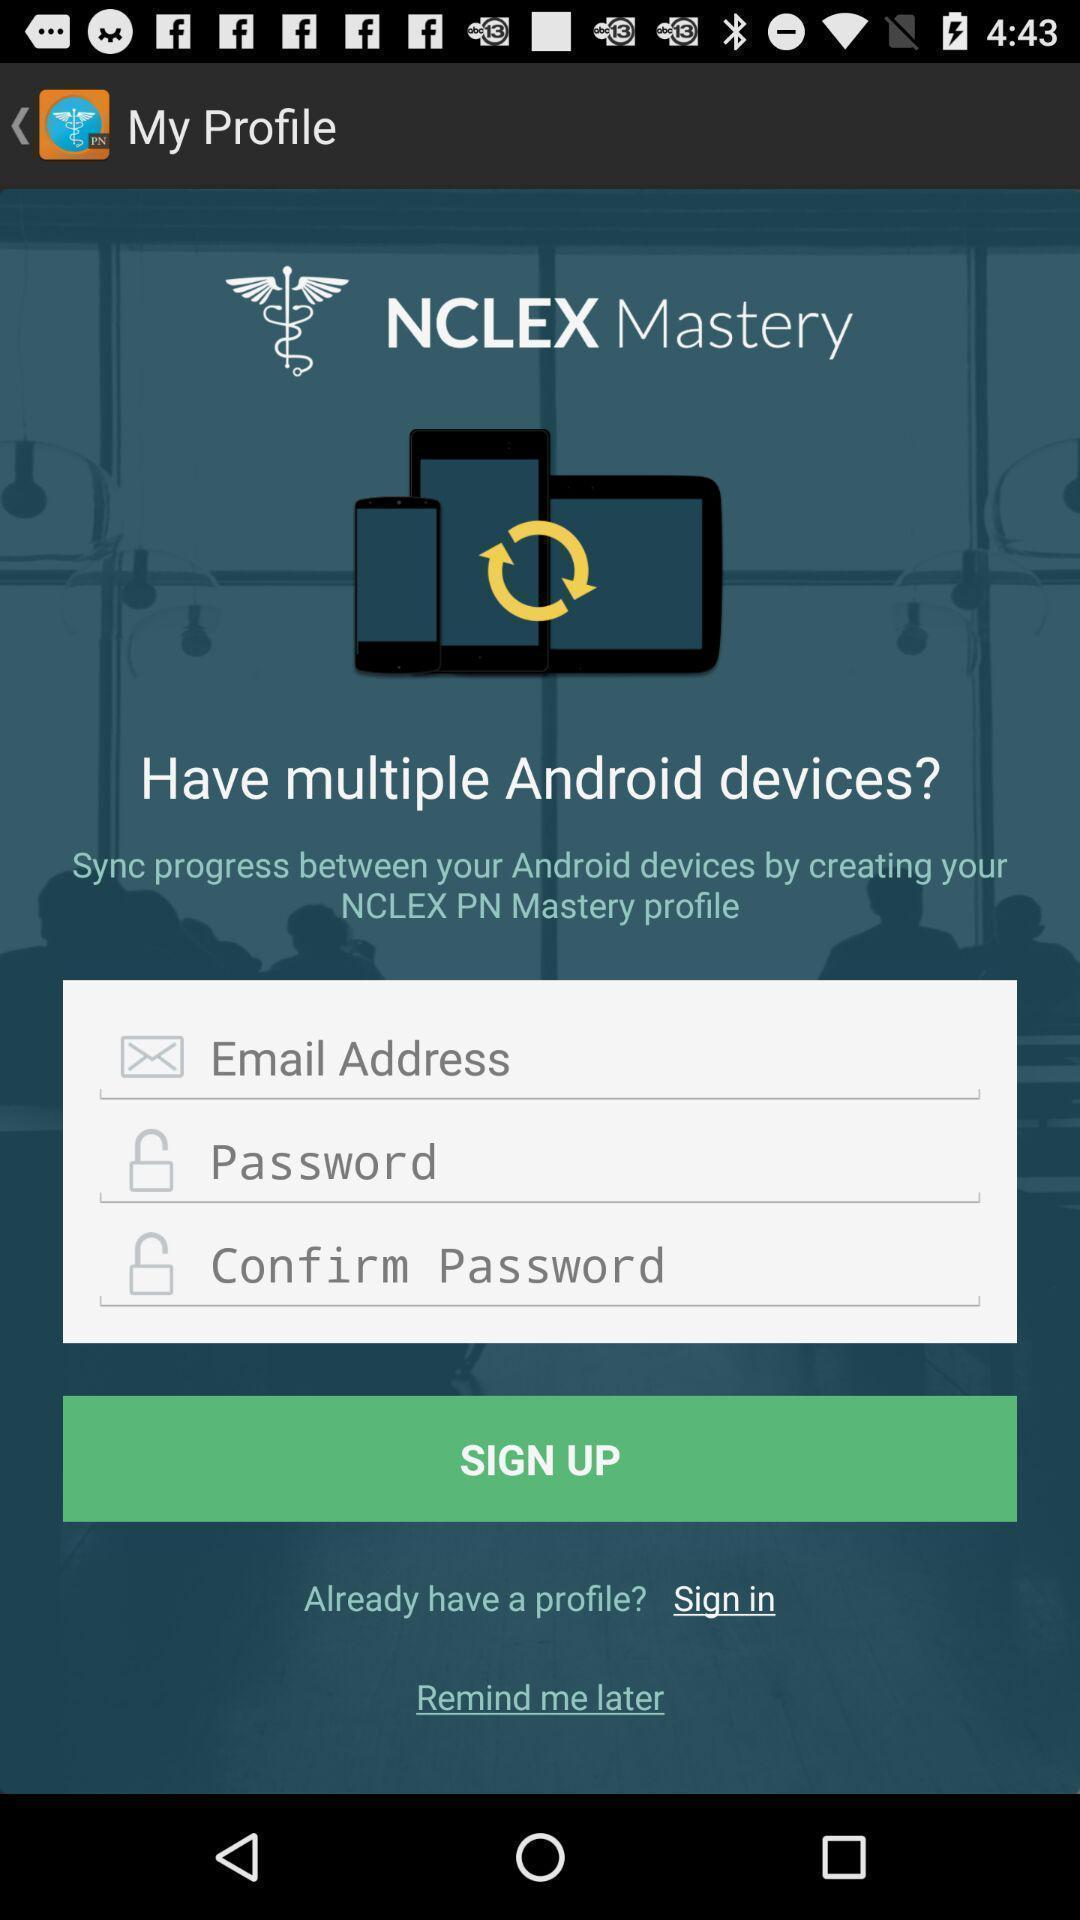What can you discern from this picture? Sign up page. 